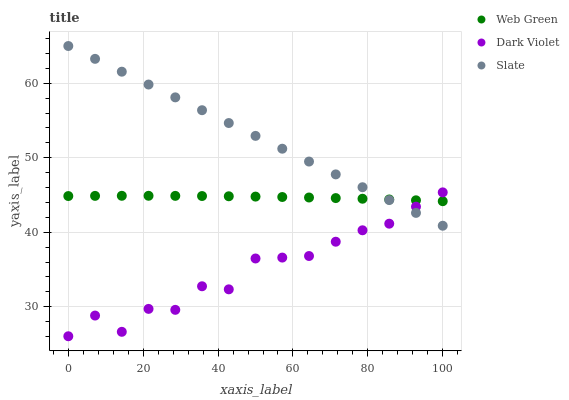Does Dark Violet have the minimum area under the curve?
Answer yes or no. Yes. Does Slate have the maximum area under the curve?
Answer yes or no. Yes. Does Web Green have the minimum area under the curve?
Answer yes or no. No. Does Web Green have the maximum area under the curve?
Answer yes or no. No. Is Slate the smoothest?
Answer yes or no. Yes. Is Dark Violet the roughest?
Answer yes or no. Yes. Is Web Green the smoothest?
Answer yes or no. No. Is Web Green the roughest?
Answer yes or no. No. Does Dark Violet have the lowest value?
Answer yes or no. Yes. Does Web Green have the lowest value?
Answer yes or no. No. Does Slate have the highest value?
Answer yes or no. Yes. Does Dark Violet have the highest value?
Answer yes or no. No. Does Web Green intersect Dark Violet?
Answer yes or no. Yes. Is Web Green less than Dark Violet?
Answer yes or no. No. Is Web Green greater than Dark Violet?
Answer yes or no. No. 